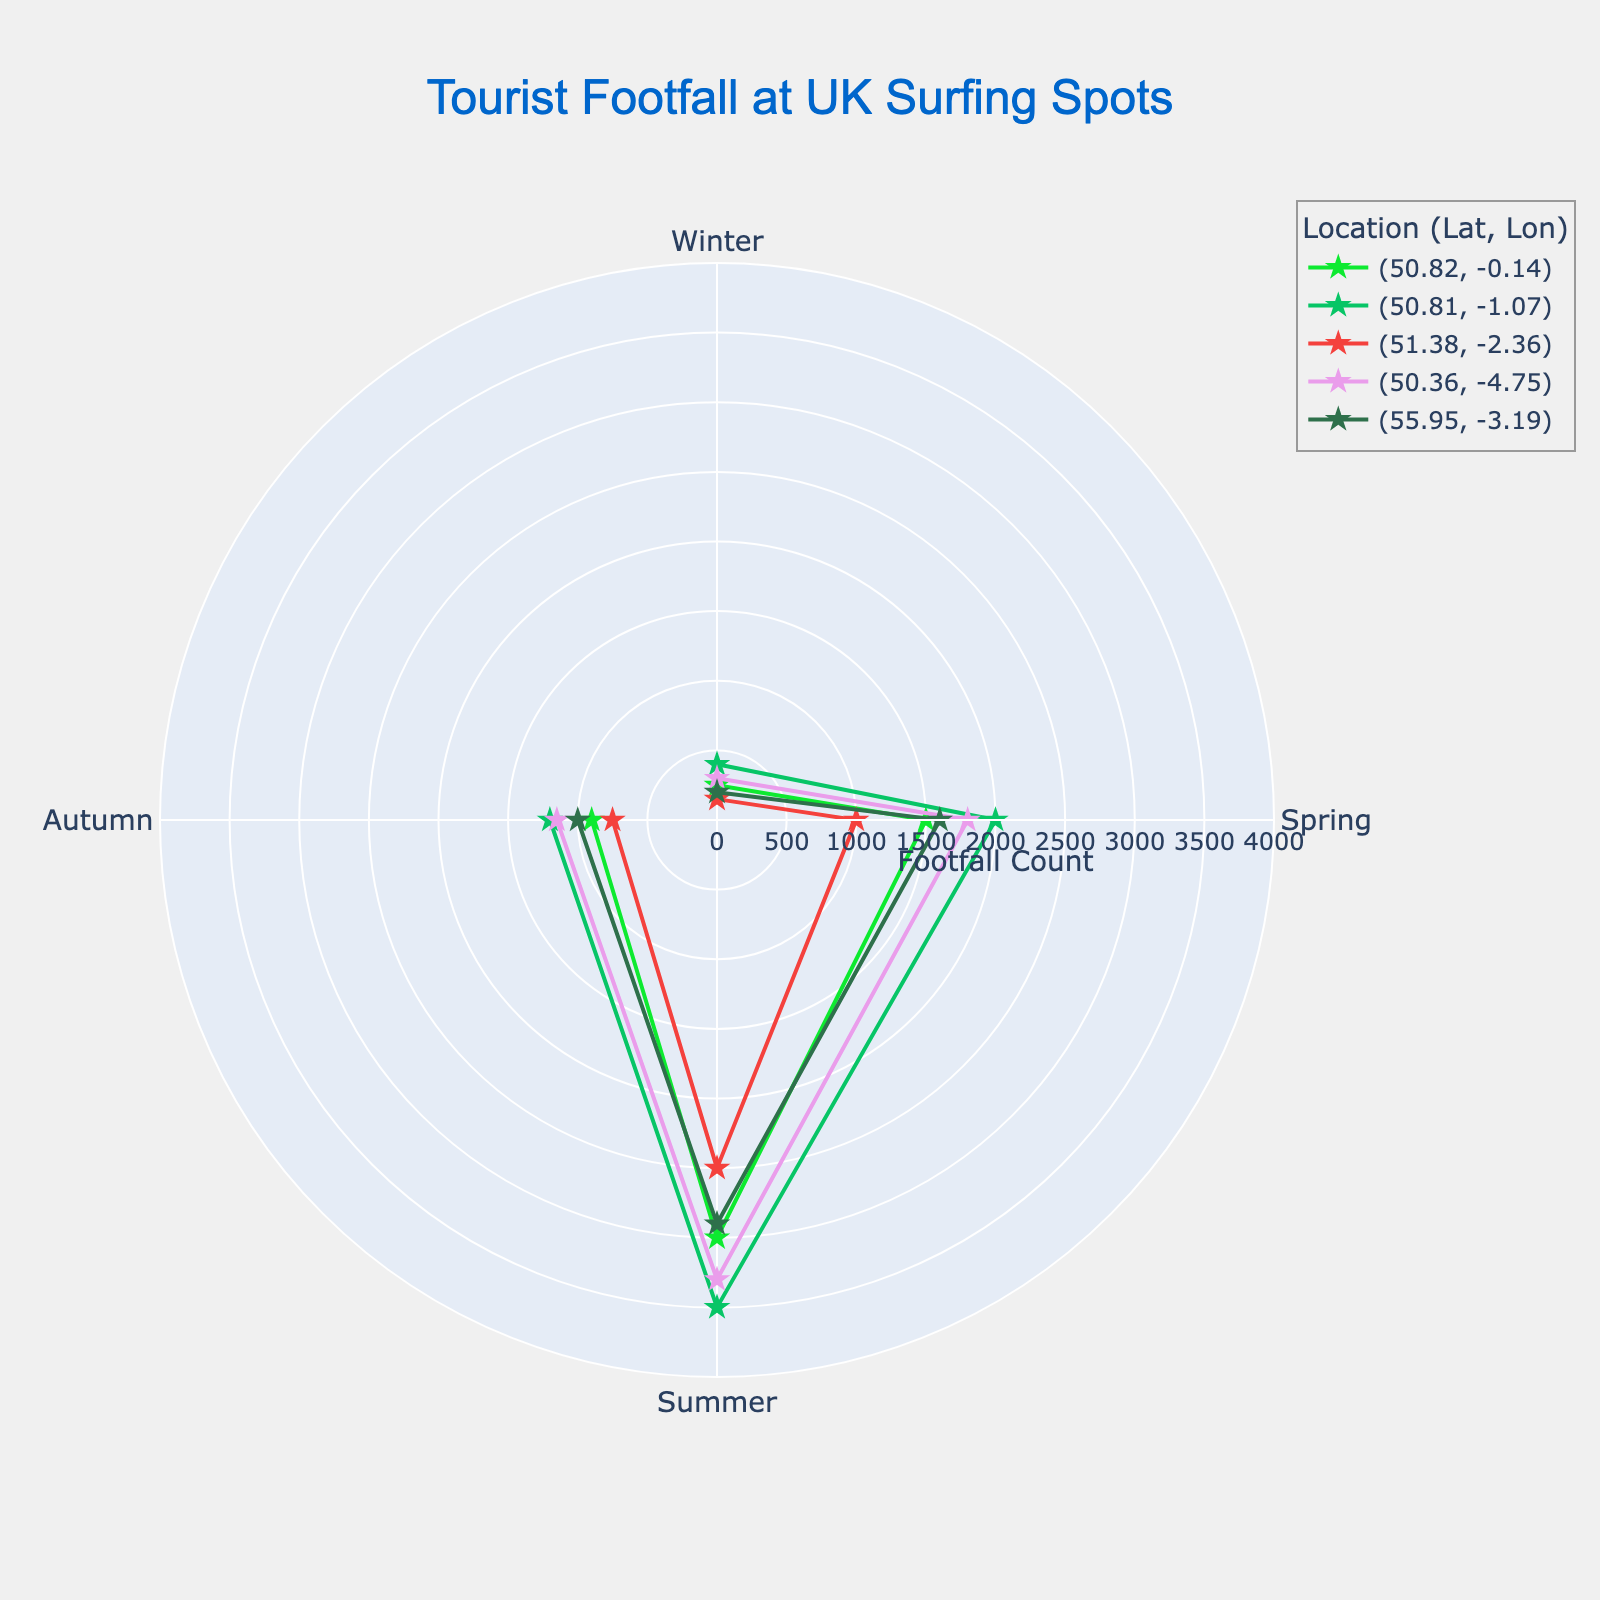Which season has the lowest footfall at the surfing spot with coordinates (51.38, -2.36)? Look at the data points plotted for the coordinates (51.38, -2.36). The labeled radial distances reveal that winter has the lowest footfall count.
Answer: Winter What's the title of this chart? The title is typically located at the top of the chart; it states: "Tourist Footfall at UK Surfing Spots".
Answer: Tourist Footfall at UK Surfing Spots How many seasons are depicted on the chart? The polar scatter chart shows data points corresponding to the four seasons typically labeled around the angular axis: Winter, Spring, Summer, and Autumn.
Answer: 4 Which location has the highest tourist footfall in summer? To find the location with the highest tourist footfall in summer, compare the radial distances positing the largest value. The coordinates (50.81, -1.07) show the highest value in summer.
Answer: (50.81, -1.07) What is the approximate tourist footfall count for (50.36, -4.75) in spring? Locate the sky-blue colored line from the coordinates (50.36, -4.75). The radial distance shows around 1,800 tourists in spring.
Answer: 1800 Which season generally has the highest footfall across all locations? Examining the radial distance for all the locations, summer displays the highest footfall counts.
Answer: Summer How does the tourist footfall count in autumn compare between the location (55.95, -3.19) and (50.82, -0.14)? Identify the two corresponding autumn radial marks. The values show counts are higher for (50.82, -0.14) than (55.95, -3.19).
Answer: (50.82, -0.14) is higher What’s the average tourist footfall in winter across all locations? Sum the winter footfall counts at each location: 250 + 400 + 150 + 300 + 200 = 1300, then divide by 5: 1300/5 = 260.
Answer: 260 How many unique locations are depicted in the polar scatter chart? Count the distinct sets of coordinates (latitude,longitude) displayed in the legend or matching color-coded lines. There are 5 unique locations.
Answer: 5 By how much does the spring footfall at (50.81, -1.07) exceed the autumn footfall at the same location? Compare the data points for spring and autumn at (50.81, -1.07): 2000 - 1200 = 800.
Answer: 800 